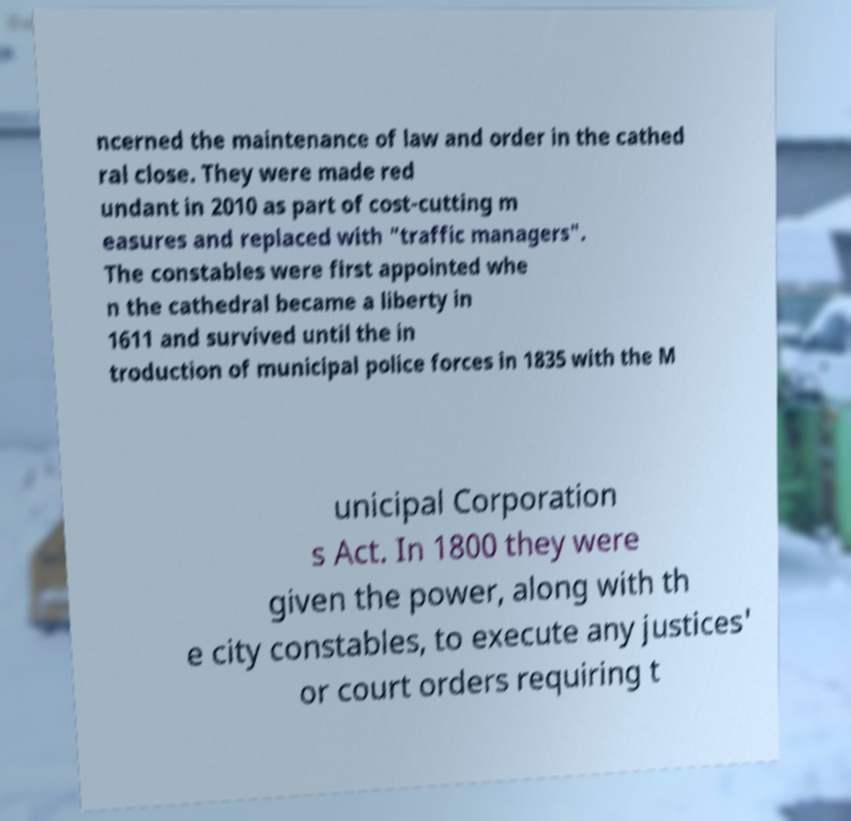I need the written content from this picture converted into text. Can you do that? ncerned the maintenance of law and order in the cathed ral close. They were made red undant in 2010 as part of cost-cutting m easures and replaced with "traffic managers". The constables were first appointed whe n the cathedral became a liberty in 1611 and survived until the in troduction of municipal police forces in 1835 with the M unicipal Corporation s Act. In 1800 they were given the power, along with th e city constables, to execute any justices' or court orders requiring t 